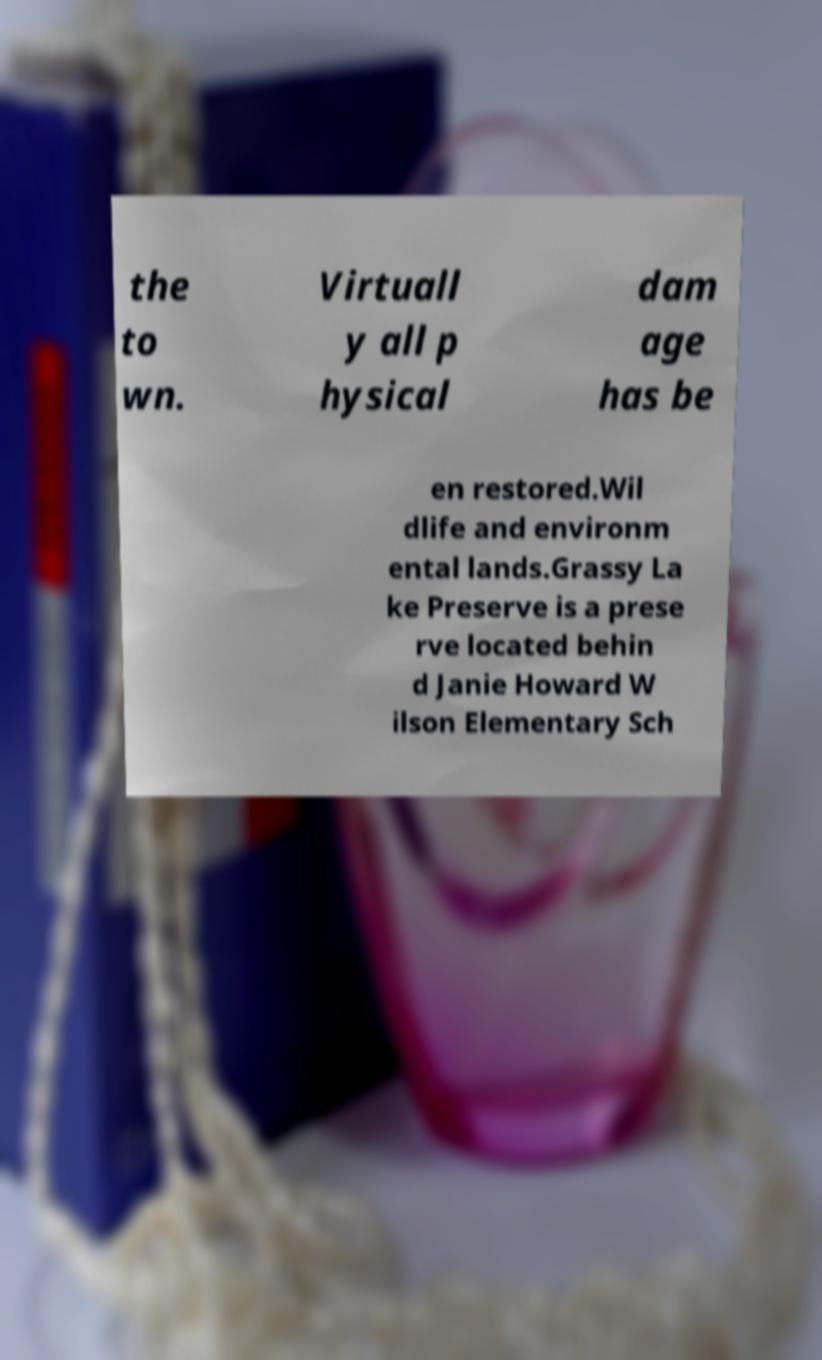What messages or text are displayed in this image? I need them in a readable, typed format. the to wn. Virtuall y all p hysical dam age has be en restored.Wil dlife and environm ental lands.Grassy La ke Preserve is a prese rve located behin d Janie Howard W ilson Elementary Sch 